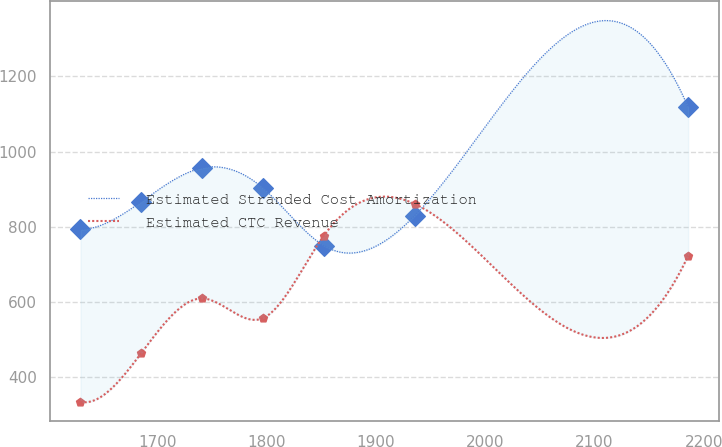Convert chart to OTSL. <chart><loc_0><loc_0><loc_500><loc_500><line_chart><ecel><fcel>Estimated Stranded Cost Amortization<fcel>Estimated CTC Revenue<nl><fcel>1629.22<fcel>792.96<fcel>334.96<nl><fcel>1684.88<fcel>866.5<fcel>464.34<nl><fcel>1740.54<fcel>956.21<fcel>609.62<nl><fcel>1796.2<fcel>903.27<fcel>557.04<nl><fcel>1851.86<fcel>750.36<fcel>775.43<nl><fcel>1935.38<fcel>829.73<fcel>860.78<nl><fcel>2185.82<fcel>1118.09<fcel>722.85<nl></chart> 